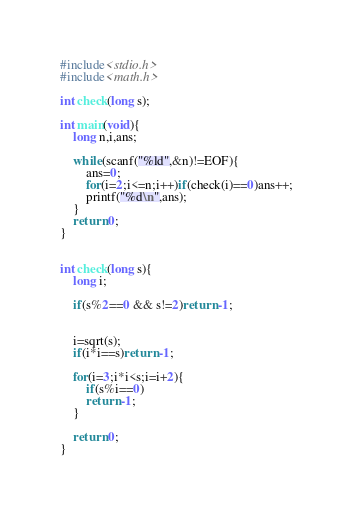Convert code to text. <code><loc_0><loc_0><loc_500><loc_500><_C_>#include<stdio.h>
#include<math.h>

int check(long s);

int main(void){
	long n,i,ans;
	
	while(scanf("%ld",&n)!=EOF){
		ans=0;
		for(i=2;i<=n;i++)if(check(i)==0)ans++;
		printf("%d\n",ans);
	}
	return 0;
}


int check(long s){
	long i;
	
	if(s%2==0 && s!=2)return -1;
	
	
	i=sqrt(s);
	if(i*i==s)return -1;
	
	for(i=3;i*i<s;i=i+2){
		if(s%i==0)
		return -1;
	}
	
	return 0;
}</code> 